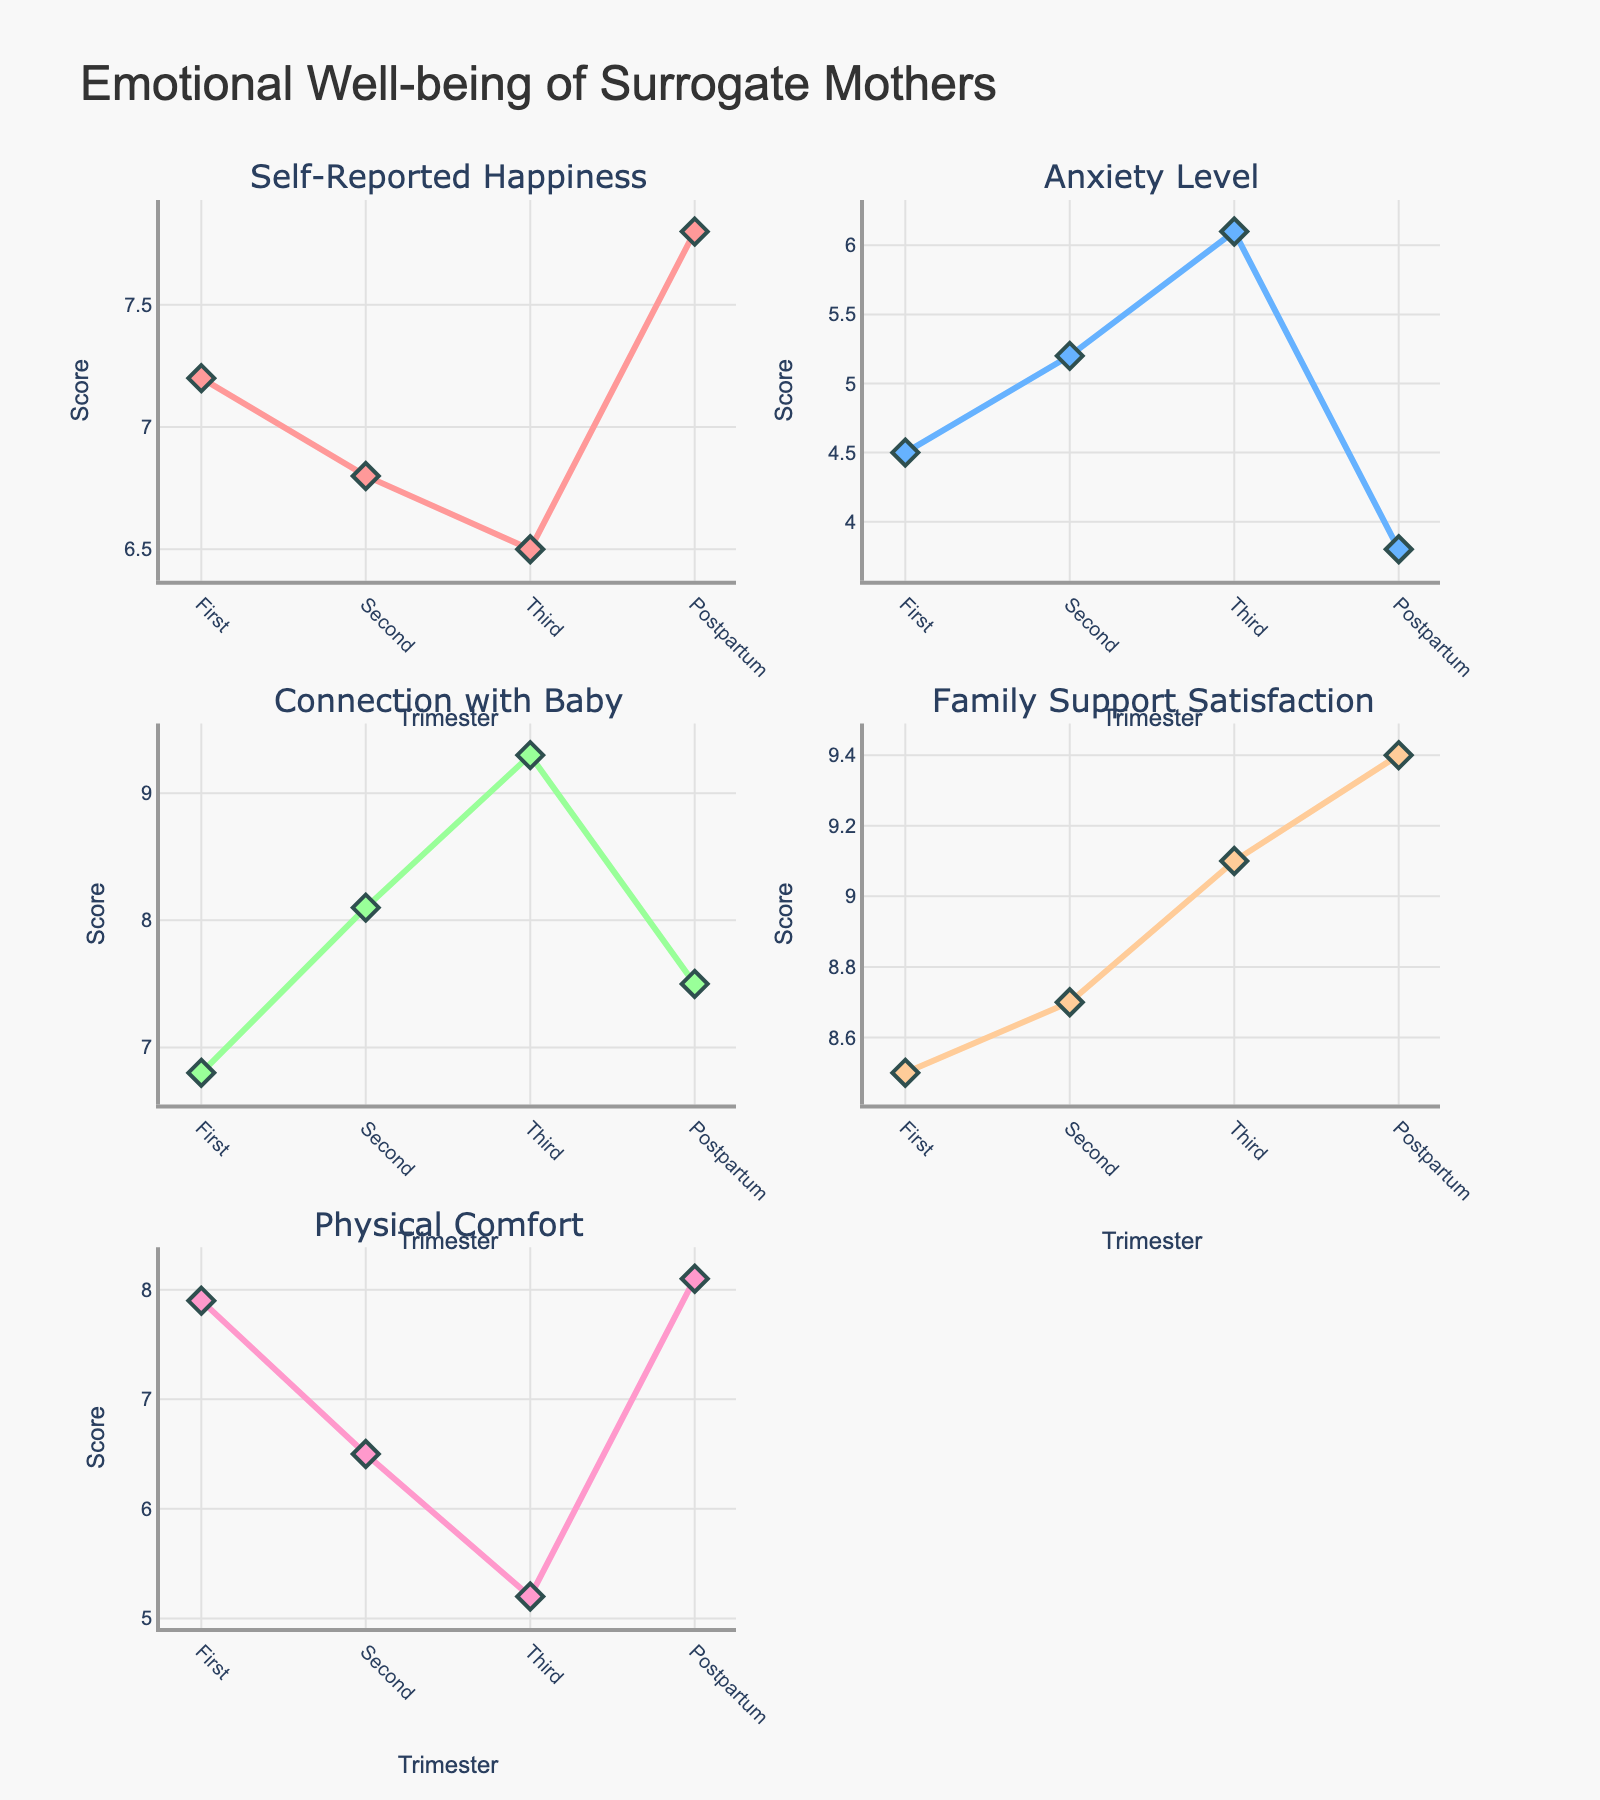What is the title of the plot? The title is written at the top center of the plot. It tells us what the plot is about.
Answer: Emotional Well-being of Surrogate Mothers How many trimesters and stages are represented in the subplots? The x-axis shows the different stages. By counting them we determine the total number.
Answer: Four (First, Second, Third, Postpartum) What color is used for "Connection with Baby"? Each subplot has a unique color for the corresponding metric, and we have to match the color with the label "Connection with Baby".
Answer: Light Blue In which stage is the Anxiety Level the highest? By looking at the subplot titled "Anxiety Level", we identify the stage with the highest score.
Answer: Third trimester What is the trend of Self-Reported Happiness over the stages of pregnancy? To understand the trend, observe if the line increases, decreases, or fluctuates from the First trimester to Postpartum.
Answer: Decreases from First to Third, then increases in Postpartum What is the difference in Family Support Satisfaction between the Second trimester and Postpartum? In the "Family Support Satisfaction" subplot, subtract the score of the Second trimester from the score of Postpartum to find the difference.
Answer: 9.4 - 8.7 = 0.7 Compare the Physical Comfort score in the Second trimester and Postpartum. Which one is higher? Look at the "Physical Comfort" subplot and compare the scores in the Second trimester and Postpartum.
Answer: Postpartum (8.1) is higher What is the average Self-Reported Happiness score across all stages? Sum the Self-Reported Happiness scores from all stages and divide by the number of stages (4).
Answer: (7.2 + 6.8 + 6.5 + 7.8) / 4 = 7.075 Which stage shows the highest score for Connection with Baby? Observe the subplot titled "Connection with Baby" and identify the stage with the peak score.
Answer: Third trimester Describe the pattern observed in Anxiety Level scores during the stages of pregnancy. Check the "Anxiety Level" subplot to see if the scores rise or fall over the stages.
Answer: Increases from First to Third, then decreases in Postpartum 